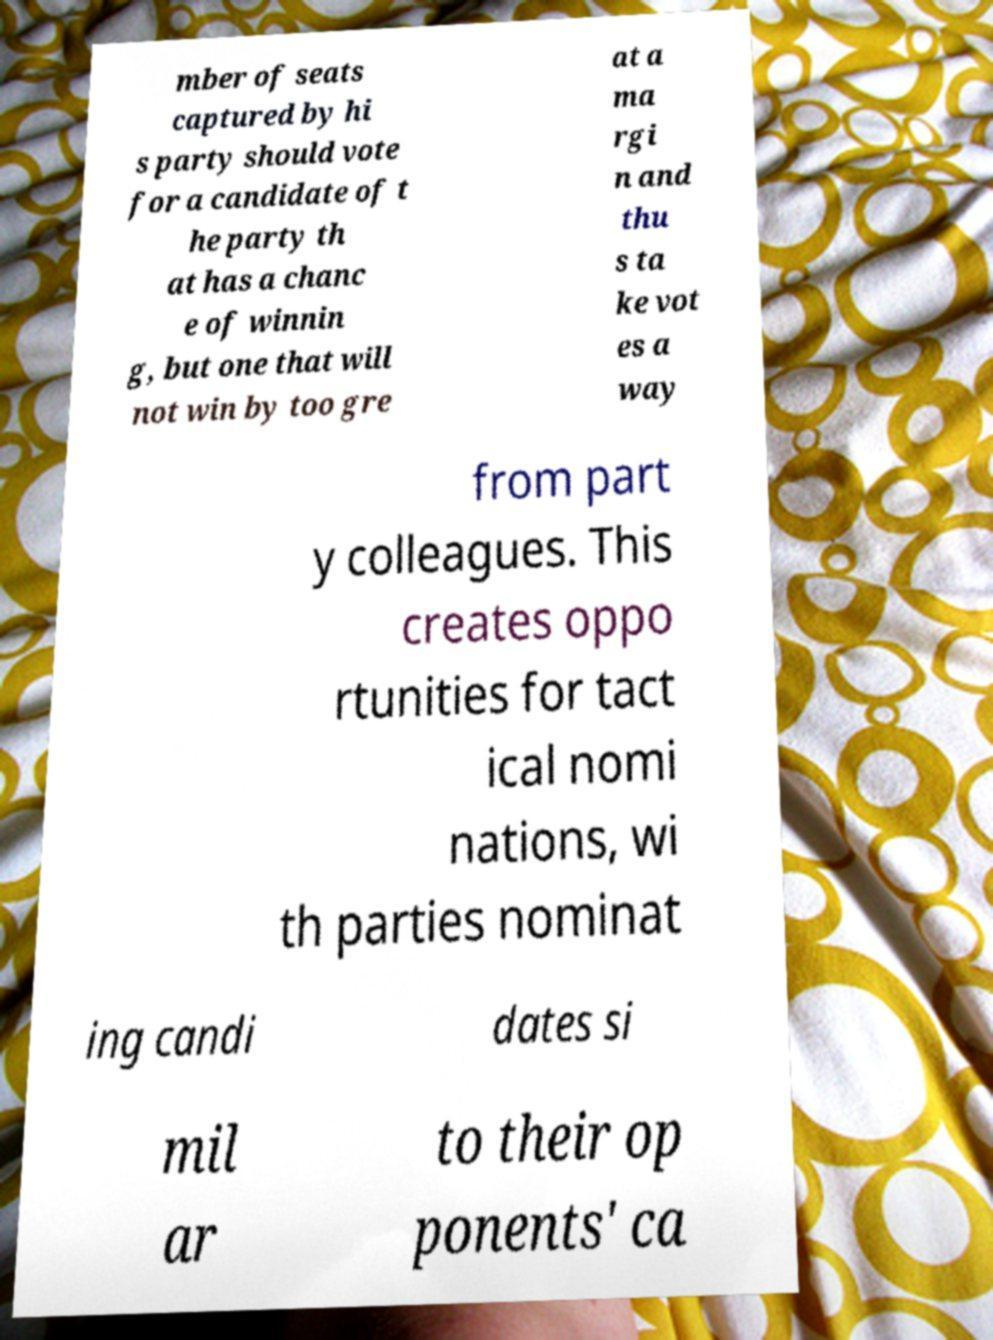Can you read and provide the text displayed in the image?This photo seems to have some interesting text. Can you extract and type it out for me? mber of seats captured by hi s party should vote for a candidate of t he party th at has a chanc e of winnin g, but one that will not win by too gre at a ma rgi n and thu s ta ke vot es a way from part y colleagues. This creates oppo rtunities for tact ical nomi nations, wi th parties nominat ing candi dates si mil ar to their op ponents' ca 